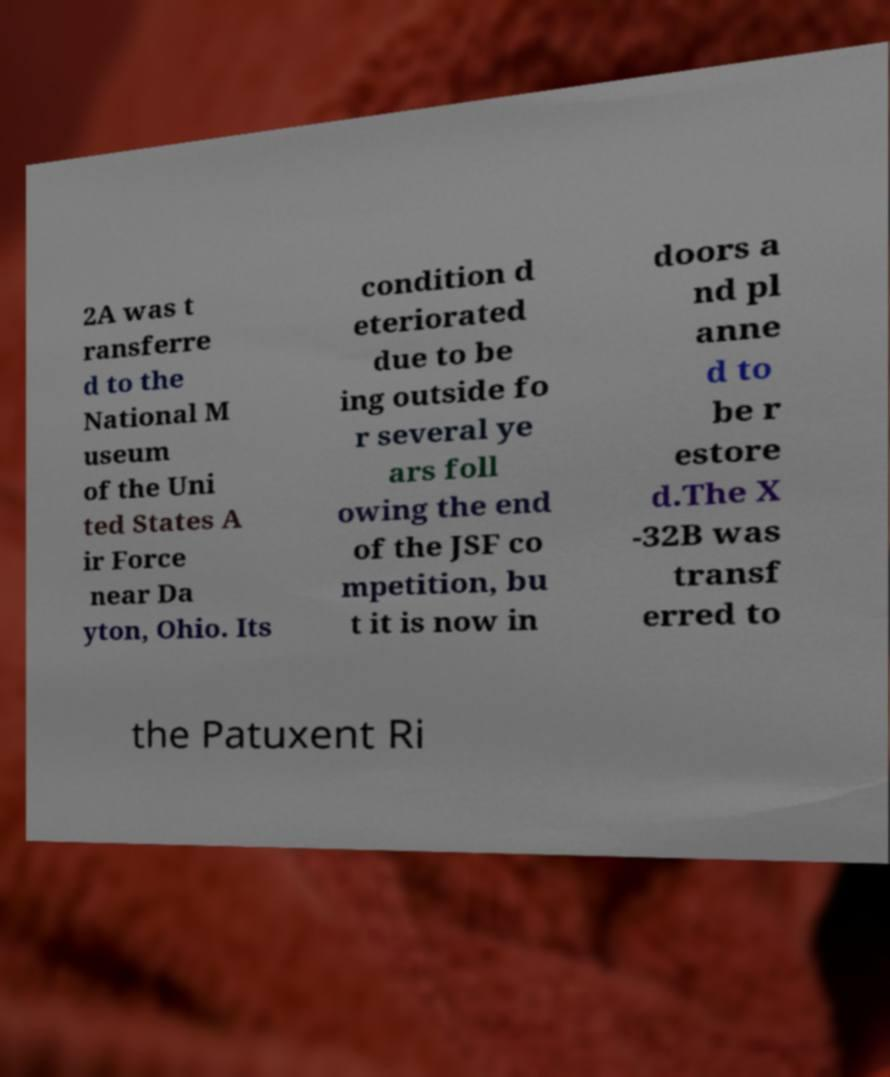Can you read and provide the text displayed in the image?This photo seems to have some interesting text. Can you extract and type it out for me? 2A was t ransferre d to the National M useum of the Uni ted States A ir Force near Da yton, Ohio. Its condition d eteriorated due to be ing outside fo r several ye ars foll owing the end of the JSF co mpetition, bu t it is now in doors a nd pl anne d to be r estore d.The X -32B was transf erred to the Patuxent Ri 